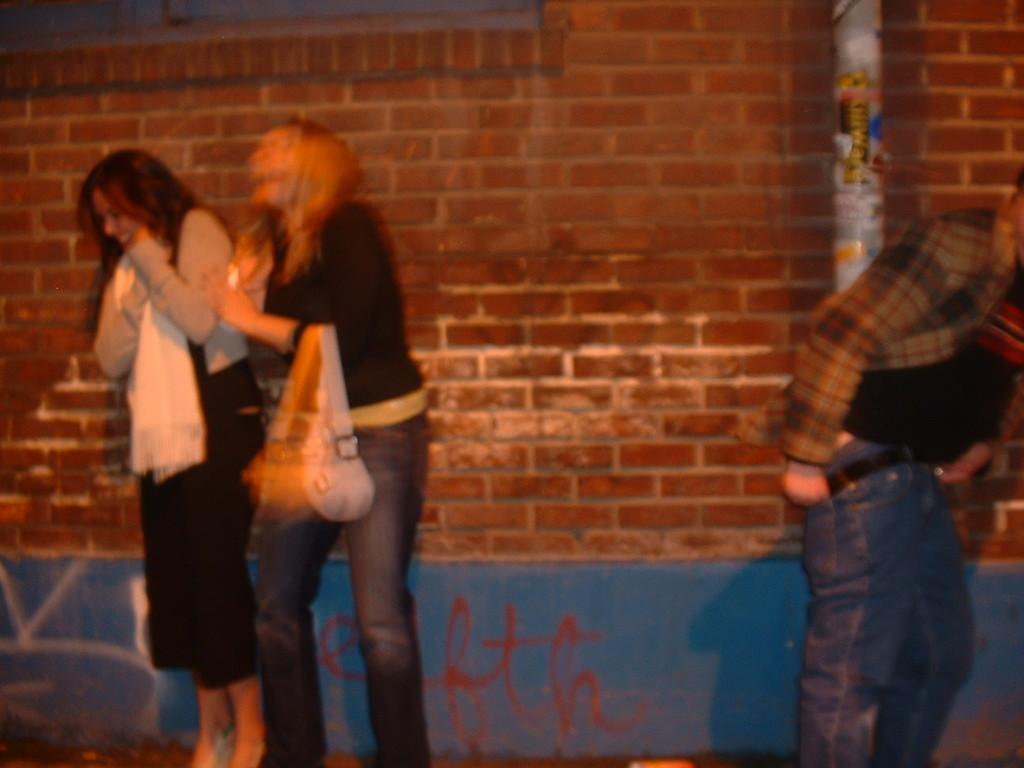How would you summarize this image in a sentence or two? In the image I can see a blurred picture of a place where we have three people, among them a lady is holding the bag and behind there is a wall on which there is something written at the bottom. 